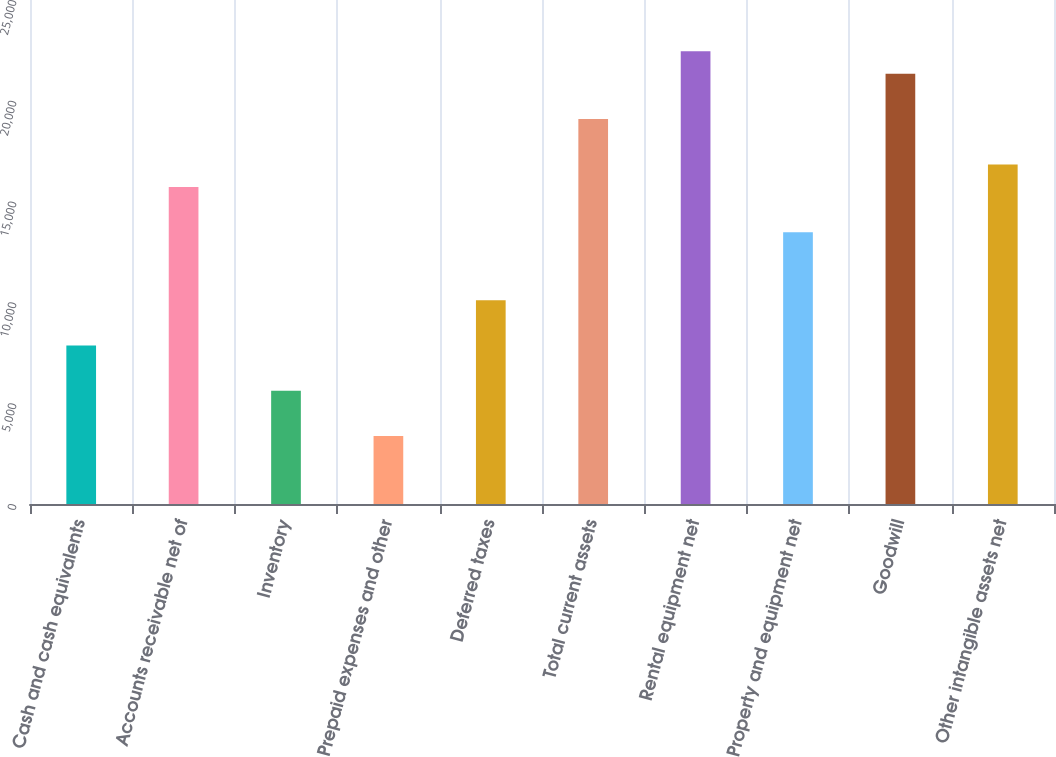<chart> <loc_0><loc_0><loc_500><loc_500><bar_chart><fcel>Cash and cash equivalents<fcel>Accounts receivable net of<fcel>Inventory<fcel>Prepaid expenses and other<fcel>Deferred taxes<fcel>Total current assets<fcel>Rental equipment net<fcel>Property and equipment net<fcel>Goodwill<fcel>Other intangible assets net<nl><fcel>7862<fcel>15723<fcel>5616<fcel>3370<fcel>10108<fcel>19092<fcel>22461<fcel>13477<fcel>21338<fcel>16846<nl></chart> 